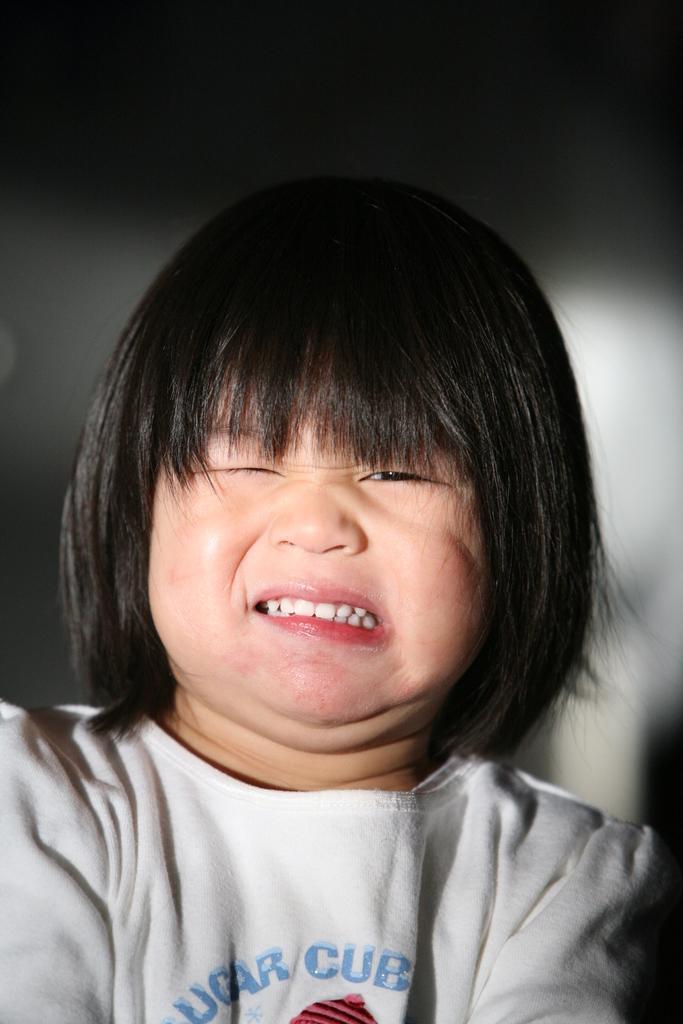Can you describe this image briefly? In this image, we can see a kid and in the background, there is a wall. 